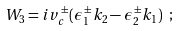Convert formula to latex. <formula><loc_0><loc_0><loc_500><loc_500>W _ { 3 } = i v _ { c } ^ { \, \pm } ( \epsilon _ { 1 } ^ { \, \pm } k _ { 2 } - \epsilon _ { 2 } ^ { \, \pm } k _ { 1 } ) \ ;</formula> 